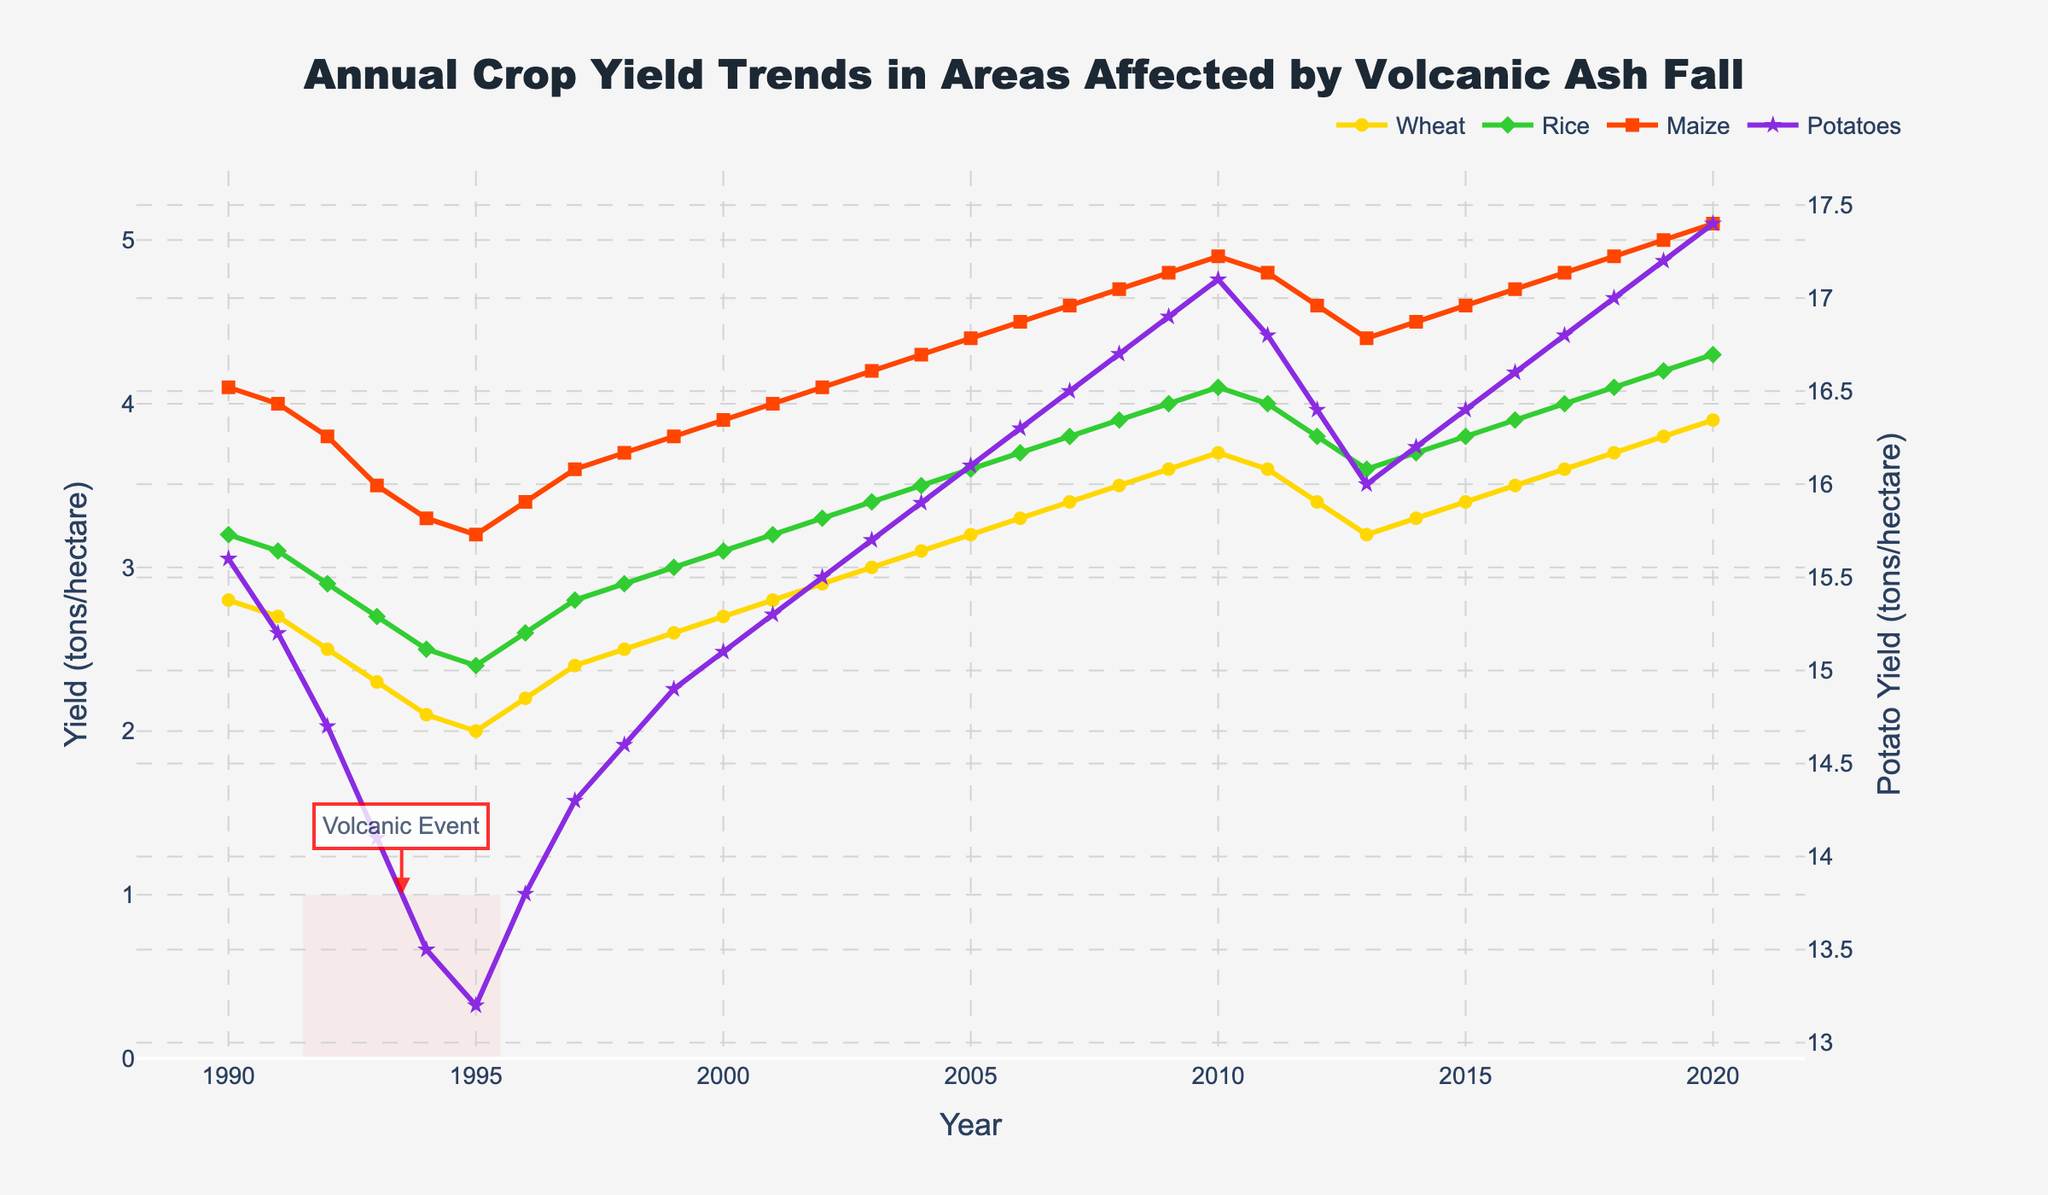What's the trend in wheat yield from 1990 to 2000? Initially there is a slight decrease from 2.8 tons/hectare in 1990 down to around 2.0 tons/hectare in 1995. However, starting from 1996, there is a gradual increase back up to around 2.8 tons/hectare by 2000.
Answer: Decrease then increase How did the volcanic event around 1992 affect the rice yield? Rice yield shows a decrease from 3.2 tons/hectare in 1990 to about 2.4 tons/hectare in 1995, marking a notable decline during the volcanic event.
Answer: Decreased Which crop showed the most resilience to the volcanic event, based on their yields during 1991-1995? Comparing all four crops, potatoes yield saw the least decline from 15.6 to 13.2 tons/hectare. In contrast, the others experienced a higher percentage drop in yields.
Answer: Potatoes What's the difference in maize yield between the year 1990 and 2020? In 1990, maize yield was 4.1 tons/hectare, and in 2020 it was 5.1 tons/hectare. The difference is calculated as 5.1 - 4.1.
Answer: 1.0 tons/hectare Which crop showed the highest increase in yield from 1995 to 2020? Calculate the yield increase for each crop during this period: Wheat from 2.0 to 3.9 (increase of 1.9), Rice from 2.4 to 4.3 (increase of 1.9), Maize 3.2 to 5.1 (increase of 1.9), Potatoes from 13.2 to 17.4 (increase of 4.2). Potatoes showed the highest increase.
Answer: Potatoes Did any crop yield return to pre-volcanic levels by 2000? By 2000, yields for all crops had returned to or exceeded their pre-volcanic levels. Wheat returned to 2.8, Rice to 3.1, Maize to 3.8, and Potatoes to 14.9, close to their 1990 values.
Answer: Yes, all Which year observed the lowest potato yield, and what was its value? From the plotted data, the lowest potato yield was observed in 1995, with a value of 13.2 tons/hectare.
Answer: 1995, 13.2 tons/hectare During which years did the wheat yield show a consistent increase? Post-1995, wheat yield consistently increased each year from 2.0 tons/hectare in 1995 to approximately 3.7 tons/hectare by 2010.
Answer: 1995 to 2010 By looking at the trends, which crop seems least affected by the initial volcanic event impact? While all crops were impacted, potatoes had the smallest relative decline and quickest recovery, as observed by a smaller drop between 1991 and 1995 and a gradual increase thereafter.
Answer: Potatoes 